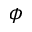<formula> <loc_0><loc_0><loc_500><loc_500>\phi</formula> 